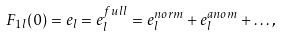Convert formula to latex. <formula><loc_0><loc_0><loc_500><loc_500>F _ { 1 l } ( 0 ) = e _ { l } = e _ { l } ^ { f u l l } = e _ { l } ^ { n o r m } + e _ { l } ^ { a n o m } + \dots ,</formula> 